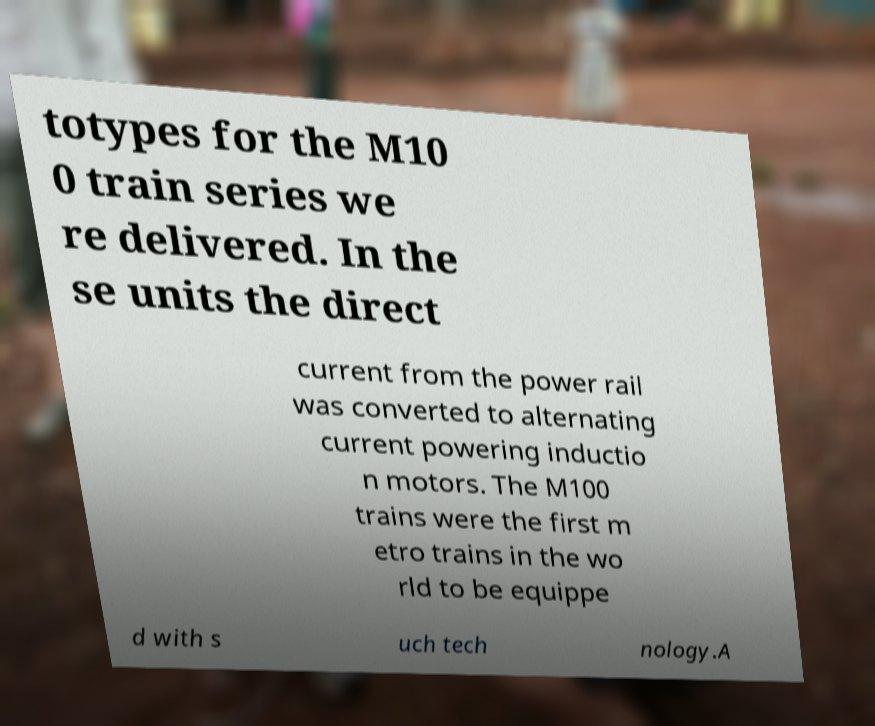Please read and relay the text visible in this image. What does it say? totypes for the M10 0 train series we re delivered. In the se units the direct current from the power rail was converted to alternating current powering inductio n motors. The M100 trains were the first m etro trains in the wo rld to be equippe d with s uch tech nology.A 